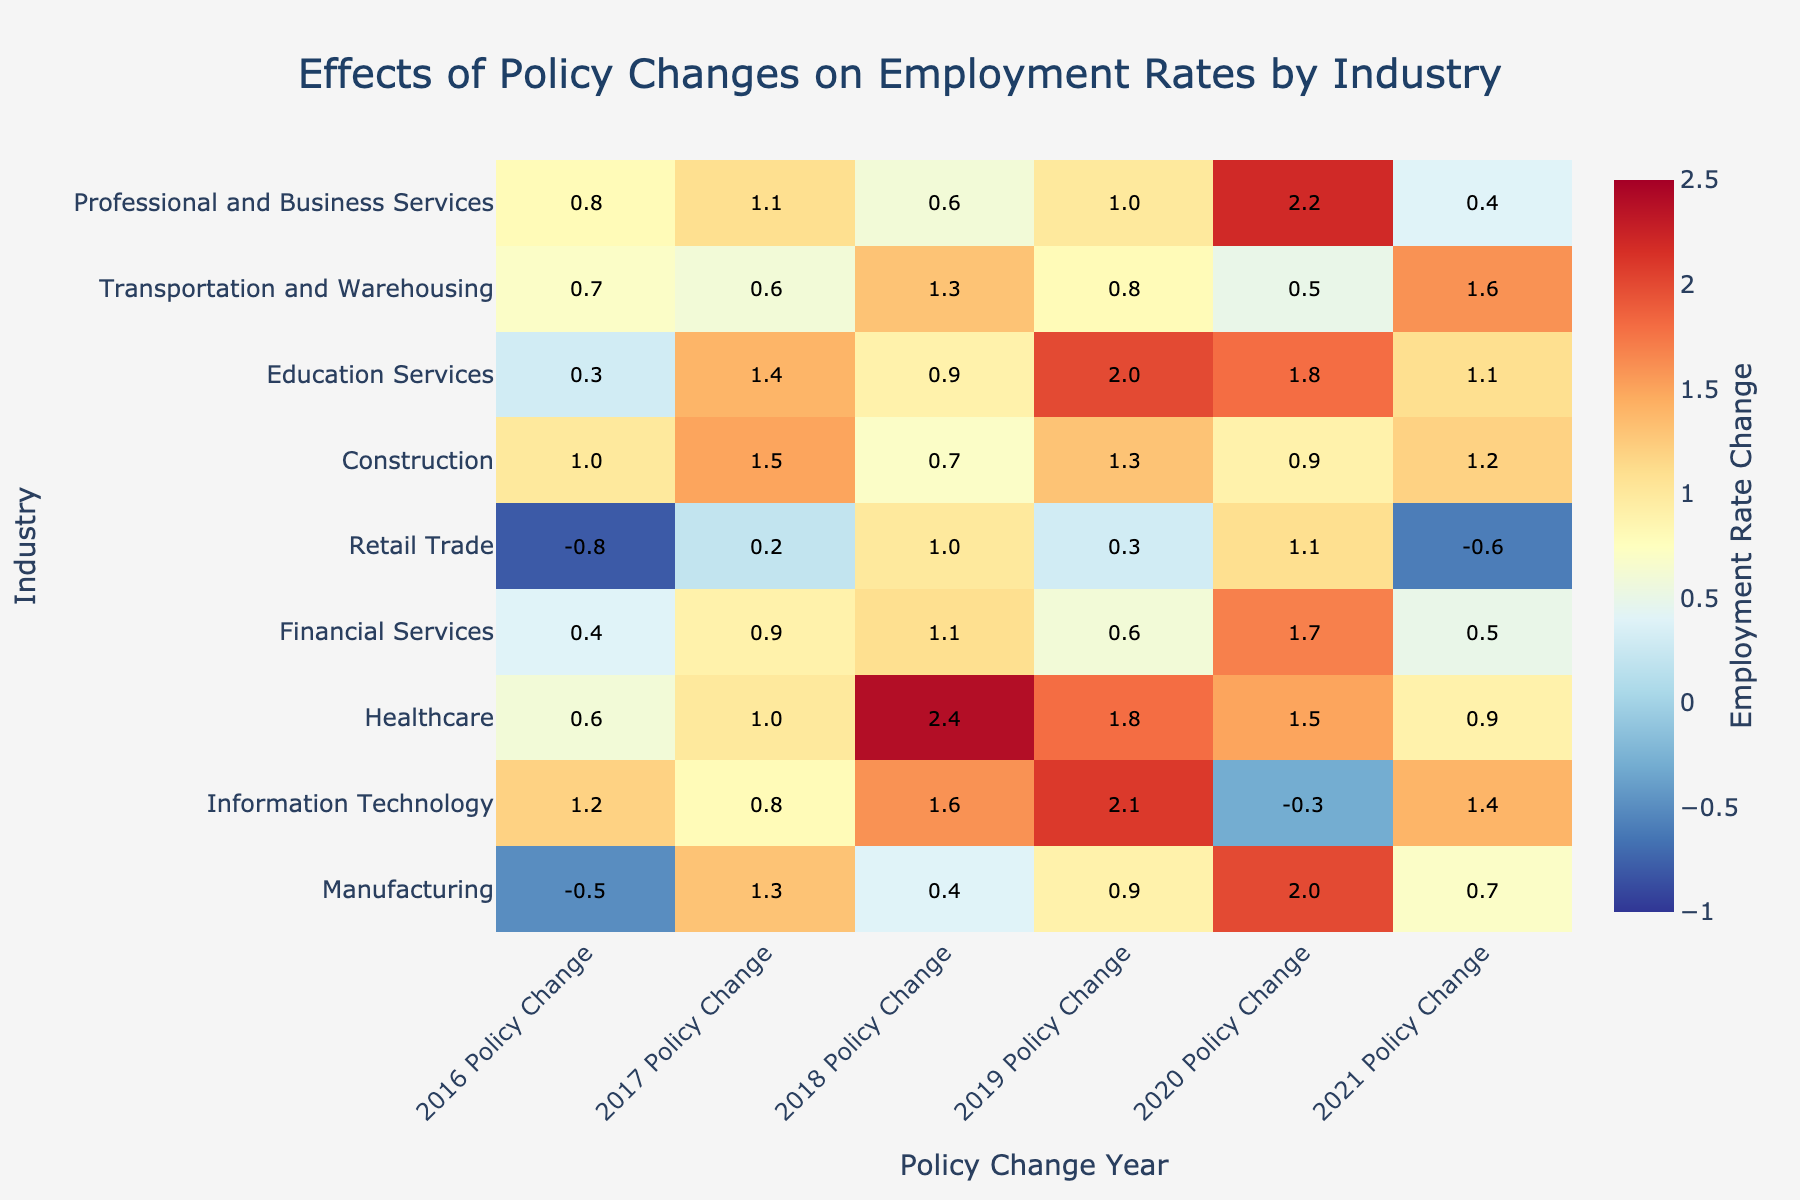What's the title of the heatmap? The title is presented at the top of the heatmap, which is "Effects of Policy Changes on Employment Rates by Industry".
Answer: Effects of Policy Changes on Employment Rates by Industry Which industry had the highest employment rate change in 2020? Look at the column for 2020 and find the highest value across all industries. The highest value in 2020 is "2.2" which is for "Professional and Business Services".
Answer: Professional and Business Services What was the employment rate change for the Manufacturing industry in 2016? Locate the Manufacturing row and then look at the 2016 column to find the value. The value is "-0.5".
Answer: -0.5 Which year had the most positive employment rate change for the Information Technology industry? Look at the values in the row for Information Technology and identify the year corresponding to the highest positive value, which is "2.1" in 2019.
Answer: 2019 Which industry experienced a decrease in employment rates in 2021? Check the 2021 column and find any negative values. The industry with a decrease is "Retail Trade" with "-0.6".
Answer: Retail Trade What is the average employment rate change for the Healthcare industry from 2016 to 2021? Sum up the values for Healthcare from 2016 to 2021: (0.6 + 1.0 + 2.4 + 1.8 + 1.5 + 0.9) = 8.2, then divide by the number of years (6). The average is 8.2 / 6 = 1.37.
Answer: 1.37 Which industry showed the smallest variation in employment rate changes over the years? Look at the values for each industry and calculate the range (maximum value minus minimum value) for each. The range for "Financial Services" is the smallest: Maximum (1.7) - Minimum (0.4) = 1.3.
Answer: Financial Services Did any industry experience a continuous increase in employment rates for three consecutive years? Examine the values for each industry and look for any three consecutive years with consistently increasing values. For "Education Services", there is an increase from 2018 (0.9) to 2019 (2.0) and 2020 (1.8) (considering also 2017 to 2018).
Answer: Yes What was the total employment rate change for the Construction industry from 2016 to 2021? Add up the employment rate changes for the Construction industry over the years: (1.0 + 1.5 + 0.7 + 1.3 + 0.9 + 1.2) = 6.6.
Answer: 6.6 